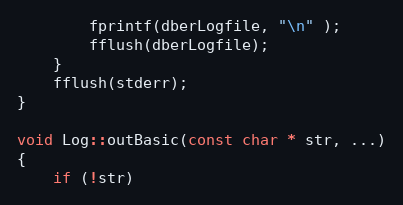<code> <loc_0><loc_0><loc_500><loc_500><_C++_>        fprintf(dberLogfile, "\n" );
        fflush(dberLogfile);
    }
    fflush(stderr);
}

void Log::outBasic(const char * str, ...)
{
    if (!str)</code> 